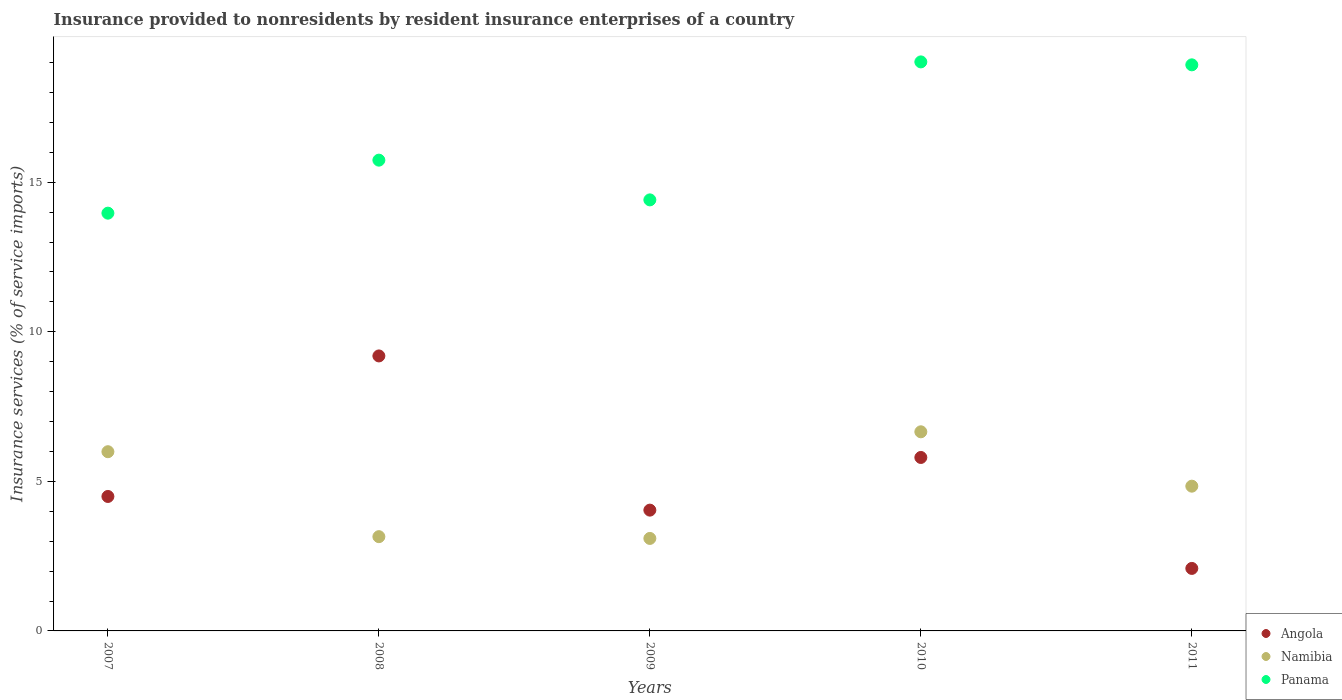How many different coloured dotlines are there?
Keep it short and to the point. 3. Is the number of dotlines equal to the number of legend labels?
Provide a succinct answer. Yes. What is the insurance provided to nonresidents in Angola in 2009?
Ensure brevity in your answer.  4.04. Across all years, what is the maximum insurance provided to nonresidents in Namibia?
Your response must be concise. 6.66. Across all years, what is the minimum insurance provided to nonresidents in Angola?
Keep it short and to the point. 2.09. What is the total insurance provided to nonresidents in Namibia in the graph?
Make the answer very short. 23.73. What is the difference between the insurance provided to nonresidents in Panama in 2009 and that in 2011?
Offer a very short reply. -4.51. What is the difference between the insurance provided to nonresidents in Angola in 2007 and the insurance provided to nonresidents in Namibia in 2008?
Make the answer very short. 1.34. What is the average insurance provided to nonresidents in Namibia per year?
Give a very brief answer. 4.75. In the year 2007, what is the difference between the insurance provided to nonresidents in Panama and insurance provided to nonresidents in Angola?
Your answer should be very brief. 9.47. What is the ratio of the insurance provided to nonresidents in Panama in 2010 to that in 2011?
Ensure brevity in your answer.  1.01. What is the difference between the highest and the second highest insurance provided to nonresidents in Angola?
Your answer should be very brief. 3.39. What is the difference between the highest and the lowest insurance provided to nonresidents in Namibia?
Give a very brief answer. 3.56. In how many years, is the insurance provided to nonresidents in Namibia greater than the average insurance provided to nonresidents in Namibia taken over all years?
Offer a terse response. 3. Is it the case that in every year, the sum of the insurance provided to nonresidents in Namibia and insurance provided to nonresidents in Panama  is greater than the insurance provided to nonresidents in Angola?
Your answer should be compact. Yes. Does the insurance provided to nonresidents in Namibia monotonically increase over the years?
Give a very brief answer. No. Is the insurance provided to nonresidents in Namibia strictly greater than the insurance provided to nonresidents in Panama over the years?
Provide a succinct answer. No. Is the insurance provided to nonresidents in Namibia strictly less than the insurance provided to nonresidents in Panama over the years?
Offer a terse response. Yes. How many dotlines are there?
Offer a terse response. 3. How many years are there in the graph?
Your answer should be compact. 5. Are the values on the major ticks of Y-axis written in scientific E-notation?
Your answer should be compact. No. Does the graph contain any zero values?
Make the answer very short. No. Does the graph contain grids?
Your answer should be very brief. No. How many legend labels are there?
Ensure brevity in your answer.  3. How are the legend labels stacked?
Offer a very short reply. Vertical. What is the title of the graph?
Make the answer very short. Insurance provided to nonresidents by resident insurance enterprises of a country. What is the label or title of the Y-axis?
Provide a succinct answer. Insurance services (% of service imports). What is the Insurance services (% of service imports) of Angola in 2007?
Offer a very short reply. 4.49. What is the Insurance services (% of service imports) in Namibia in 2007?
Your answer should be very brief. 5.99. What is the Insurance services (% of service imports) of Panama in 2007?
Your answer should be compact. 13.97. What is the Insurance services (% of service imports) in Angola in 2008?
Provide a succinct answer. 9.19. What is the Insurance services (% of service imports) of Namibia in 2008?
Provide a short and direct response. 3.15. What is the Insurance services (% of service imports) in Panama in 2008?
Offer a very short reply. 15.74. What is the Insurance services (% of service imports) in Angola in 2009?
Offer a very short reply. 4.04. What is the Insurance services (% of service imports) in Namibia in 2009?
Your answer should be compact. 3.09. What is the Insurance services (% of service imports) of Panama in 2009?
Ensure brevity in your answer.  14.41. What is the Insurance services (% of service imports) in Angola in 2010?
Your response must be concise. 5.8. What is the Insurance services (% of service imports) of Namibia in 2010?
Offer a very short reply. 6.66. What is the Insurance services (% of service imports) in Panama in 2010?
Your answer should be compact. 19.02. What is the Insurance services (% of service imports) in Angola in 2011?
Provide a succinct answer. 2.09. What is the Insurance services (% of service imports) of Namibia in 2011?
Your response must be concise. 4.84. What is the Insurance services (% of service imports) in Panama in 2011?
Offer a terse response. 18.92. Across all years, what is the maximum Insurance services (% of service imports) in Angola?
Give a very brief answer. 9.19. Across all years, what is the maximum Insurance services (% of service imports) in Namibia?
Provide a succinct answer. 6.66. Across all years, what is the maximum Insurance services (% of service imports) in Panama?
Offer a terse response. 19.02. Across all years, what is the minimum Insurance services (% of service imports) in Angola?
Offer a terse response. 2.09. Across all years, what is the minimum Insurance services (% of service imports) of Namibia?
Your answer should be compact. 3.09. Across all years, what is the minimum Insurance services (% of service imports) of Panama?
Offer a very short reply. 13.97. What is the total Insurance services (% of service imports) in Angola in the graph?
Your answer should be compact. 25.61. What is the total Insurance services (% of service imports) of Namibia in the graph?
Your answer should be compact. 23.73. What is the total Insurance services (% of service imports) of Panama in the graph?
Provide a succinct answer. 82.06. What is the difference between the Insurance services (% of service imports) of Angola in 2007 and that in 2008?
Give a very brief answer. -4.7. What is the difference between the Insurance services (% of service imports) of Namibia in 2007 and that in 2008?
Your response must be concise. 2.84. What is the difference between the Insurance services (% of service imports) of Panama in 2007 and that in 2008?
Your response must be concise. -1.77. What is the difference between the Insurance services (% of service imports) of Angola in 2007 and that in 2009?
Provide a succinct answer. 0.46. What is the difference between the Insurance services (% of service imports) in Namibia in 2007 and that in 2009?
Offer a terse response. 2.9. What is the difference between the Insurance services (% of service imports) of Panama in 2007 and that in 2009?
Give a very brief answer. -0.44. What is the difference between the Insurance services (% of service imports) of Angola in 2007 and that in 2010?
Your answer should be very brief. -1.3. What is the difference between the Insurance services (% of service imports) of Namibia in 2007 and that in 2010?
Ensure brevity in your answer.  -0.67. What is the difference between the Insurance services (% of service imports) of Panama in 2007 and that in 2010?
Give a very brief answer. -5.06. What is the difference between the Insurance services (% of service imports) of Angola in 2007 and that in 2011?
Offer a terse response. 2.41. What is the difference between the Insurance services (% of service imports) of Namibia in 2007 and that in 2011?
Offer a very short reply. 1.15. What is the difference between the Insurance services (% of service imports) of Panama in 2007 and that in 2011?
Your response must be concise. -4.96. What is the difference between the Insurance services (% of service imports) of Angola in 2008 and that in 2009?
Keep it short and to the point. 5.15. What is the difference between the Insurance services (% of service imports) of Namibia in 2008 and that in 2009?
Your answer should be very brief. 0.06. What is the difference between the Insurance services (% of service imports) in Panama in 2008 and that in 2009?
Provide a succinct answer. 1.33. What is the difference between the Insurance services (% of service imports) in Angola in 2008 and that in 2010?
Give a very brief answer. 3.39. What is the difference between the Insurance services (% of service imports) of Namibia in 2008 and that in 2010?
Make the answer very short. -3.51. What is the difference between the Insurance services (% of service imports) in Panama in 2008 and that in 2010?
Ensure brevity in your answer.  -3.28. What is the difference between the Insurance services (% of service imports) of Angola in 2008 and that in 2011?
Your answer should be compact. 7.1. What is the difference between the Insurance services (% of service imports) of Namibia in 2008 and that in 2011?
Offer a very short reply. -1.69. What is the difference between the Insurance services (% of service imports) in Panama in 2008 and that in 2011?
Ensure brevity in your answer.  -3.19. What is the difference between the Insurance services (% of service imports) in Angola in 2009 and that in 2010?
Ensure brevity in your answer.  -1.76. What is the difference between the Insurance services (% of service imports) of Namibia in 2009 and that in 2010?
Provide a succinct answer. -3.56. What is the difference between the Insurance services (% of service imports) in Panama in 2009 and that in 2010?
Give a very brief answer. -4.61. What is the difference between the Insurance services (% of service imports) of Angola in 2009 and that in 2011?
Your response must be concise. 1.95. What is the difference between the Insurance services (% of service imports) of Namibia in 2009 and that in 2011?
Your response must be concise. -1.75. What is the difference between the Insurance services (% of service imports) in Panama in 2009 and that in 2011?
Make the answer very short. -4.51. What is the difference between the Insurance services (% of service imports) of Angola in 2010 and that in 2011?
Your response must be concise. 3.71. What is the difference between the Insurance services (% of service imports) in Namibia in 2010 and that in 2011?
Your answer should be very brief. 1.82. What is the difference between the Insurance services (% of service imports) in Panama in 2010 and that in 2011?
Offer a terse response. 0.1. What is the difference between the Insurance services (% of service imports) of Angola in 2007 and the Insurance services (% of service imports) of Namibia in 2008?
Provide a succinct answer. 1.34. What is the difference between the Insurance services (% of service imports) in Angola in 2007 and the Insurance services (% of service imports) in Panama in 2008?
Keep it short and to the point. -11.24. What is the difference between the Insurance services (% of service imports) in Namibia in 2007 and the Insurance services (% of service imports) in Panama in 2008?
Provide a short and direct response. -9.75. What is the difference between the Insurance services (% of service imports) of Angola in 2007 and the Insurance services (% of service imports) of Namibia in 2009?
Provide a short and direct response. 1.4. What is the difference between the Insurance services (% of service imports) of Angola in 2007 and the Insurance services (% of service imports) of Panama in 2009?
Your response must be concise. -9.91. What is the difference between the Insurance services (% of service imports) in Namibia in 2007 and the Insurance services (% of service imports) in Panama in 2009?
Offer a terse response. -8.42. What is the difference between the Insurance services (% of service imports) of Angola in 2007 and the Insurance services (% of service imports) of Namibia in 2010?
Provide a short and direct response. -2.16. What is the difference between the Insurance services (% of service imports) of Angola in 2007 and the Insurance services (% of service imports) of Panama in 2010?
Offer a terse response. -14.53. What is the difference between the Insurance services (% of service imports) of Namibia in 2007 and the Insurance services (% of service imports) of Panama in 2010?
Ensure brevity in your answer.  -13.03. What is the difference between the Insurance services (% of service imports) in Angola in 2007 and the Insurance services (% of service imports) in Namibia in 2011?
Keep it short and to the point. -0.34. What is the difference between the Insurance services (% of service imports) in Angola in 2007 and the Insurance services (% of service imports) in Panama in 2011?
Provide a succinct answer. -14.43. What is the difference between the Insurance services (% of service imports) in Namibia in 2007 and the Insurance services (% of service imports) in Panama in 2011?
Ensure brevity in your answer.  -12.93. What is the difference between the Insurance services (% of service imports) of Angola in 2008 and the Insurance services (% of service imports) of Namibia in 2009?
Your response must be concise. 6.1. What is the difference between the Insurance services (% of service imports) of Angola in 2008 and the Insurance services (% of service imports) of Panama in 2009?
Keep it short and to the point. -5.22. What is the difference between the Insurance services (% of service imports) in Namibia in 2008 and the Insurance services (% of service imports) in Panama in 2009?
Keep it short and to the point. -11.26. What is the difference between the Insurance services (% of service imports) in Angola in 2008 and the Insurance services (% of service imports) in Namibia in 2010?
Offer a terse response. 2.54. What is the difference between the Insurance services (% of service imports) of Angola in 2008 and the Insurance services (% of service imports) of Panama in 2010?
Make the answer very short. -9.83. What is the difference between the Insurance services (% of service imports) in Namibia in 2008 and the Insurance services (% of service imports) in Panama in 2010?
Provide a short and direct response. -15.87. What is the difference between the Insurance services (% of service imports) in Angola in 2008 and the Insurance services (% of service imports) in Namibia in 2011?
Ensure brevity in your answer.  4.35. What is the difference between the Insurance services (% of service imports) in Angola in 2008 and the Insurance services (% of service imports) in Panama in 2011?
Offer a terse response. -9.73. What is the difference between the Insurance services (% of service imports) of Namibia in 2008 and the Insurance services (% of service imports) of Panama in 2011?
Your response must be concise. -15.77. What is the difference between the Insurance services (% of service imports) in Angola in 2009 and the Insurance services (% of service imports) in Namibia in 2010?
Your response must be concise. -2.62. What is the difference between the Insurance services (% of service imports) of Angola in 2009 and the Insurance services (% of service imports) of Panama in 2010?
Provide a short and direct response. -14.98. What is the difference between the Insurance services (% of service imports) in Namibia in 2009 and the Insurance services (% of service imports) in Panama in 2010?
Make the answer very short. -15.93. What is the difference between the Insurance services (% of service imports) of Angola in 2009 and the Insurance services (% of service imports) of Namibia in 2011?
Your answer should be very brief. -0.8. What is the difference between the Insurance services (% of service imports) of Angola in 2009 and the Insurance services (% of service imports) of Panama in 2011?
Your response must be concise. -14.89. What is the difference between the Insurance services (% of service imports) in Namibia in 2009 and the Insurance services (% of service imports) in Panama in 2011?
Your response must be concise. -15.83. What is the difference between the Insurance services (% of service imports) in Angola in 2010 and the Insurance services (% of service imports) in Namibia in 2011?
Provide a succinct answer. 0.96. What is the difference between the Insurance services (% of service imports) of Angola in 2010 and the Insurance services (% of service imports) of Panama in 2011?
Give a very brief answer. -13.13. What is the difference between the Insurance services (% of service imports) of Namibia in 2010 and the Insurance services (% of service imports) of Panama in 2011?
Provide a succinct answer. -12.27. What is the average Insurance services (% of service imports) in Angola per year?
Keep it short and to the point. 5.12. What is the average Insurance services (% of service imports) of Namibia per year?
Your answer should be very brief. 4.75. What is the average Insurance services (% of service imports) of Panama per year?
Your answer should be very brief. 16.41. In the year 2007, what is the difference between the Insurance services (% of service imports) of Angola and Insurance services (% of service imports) of Namibia?
Provide a short and direct response. -1.5. In the year 2007, what is the difference between the Insurance services (% of service imports) in Angola and Insurance services (% of service imports) in Panama?
Your answer should be compact. -9.47. In the year 2007, what is the difference between the Insurance services (% of service imports) of Namibia and Insurance services (% of service imports) of Panama?
Keep it short and to the point. -7.97. In the year 2008, what is the difference between the Insurance services (% of service imports) of Angola and Insurance services (% of service imports) of Namibia?
Give a very brief answer. 6.04. In the year 2008, what is the difference between the Insurance services (% of service imports) of Angola and Insurance services (% of service imports) of Panama?
Offer a terse response. -6.55. In the year 2008, what is the difference between the Insurance services (% of service imports) in Namibia and Insurance services (% of service imports) in Panama?
Provide a short and direct response. -12.59. In the year 2009, what is the difference between the Insurance services (% of service imports) of Angola and Insurance services (% of service imports) of Namibia?
Offer a very short reply. 0.95. In the year 2009, what is the difference between the Insurance services (% of service imports) in Angola and Insurance services (% of service imports) in Panama?
Your answer should be compact. -10.37. In the year 2009, what is the difference between the Insurance services (% of service imports) of Namibia and Insurance services (% of service imports) of Panama?
Give a very brief answer. -11.32. In the year 2010, what is the difference between the Insurance services (% of service imports) of Angola and Insurance services (% of service imports) of Namibia?
Your answer should be very brief. -0.86. In the year 2010, what is the difference between the Insurance services (% of service imports) of Angola and Insurance services (% of service imports) of Panama?
Offer a very short reply. -13.22. In the year 2010, what is the difference between the Insurance services (% of service imports) of Namibia and Insurance services (% of service imports) of Panama?
Your answer should be very brief. -12.37. In the year 2011, what is the difference between the Insurance services (% of service imports) in Angola and Insurance services (% of service imports) in Namibia?
Ensure brevity in your answer.  -2.75. In the year 2011, what is the difference between the Insurance services (% of service imports) in Angola and Insurance services (% of service imports) in Panama?
Keep it short and to the point. -16.83. In the year 2011, what is the difference between the Insurance services (% of service imports) of Namibia and Insurance services (% of service imports) of Panama?
Your answer should be very brief. -14.09. What is the ratio of the Insurance services (% of service imports) of Angola in 2007 to that in 2008?
Offer a very short reply. 0.49. What is the ratio of the Insurance services (% of service imports) of Namibia in 2007 to that in 2008?
Provide a short and direct response. 1.9. What is the ratio of the Insurance services (% of service imports) of Panama in 2007 to that in 2008?
Keep it short and to the point. 0.89. What is the ratio of the Insurance services (% of service imports) of Angola in 2007 to that in 2009?
Make the answer very short. 1.11. What is the ratio of the Insurance services (% of service imports) in Namibia in 2007 to that in 2009?
Give a very brief answer. 1.94. What is the ratio of the Insurance services (% of service imports) in Panama in 2007 to that in 2009?
Keep it short and to the point. 0.97. What is the ratio of the Insurance services (% of service imports) in Angola in 2007 to that in 2010?
Keep it short and to the point. 0.78. What is the ratio of the Insurance services (% of service imports) of Panama in 2007 to that in 2010?
Provide a succinct answer. 0.73. What is the ratio of the Insurance services (% of service imports) of Angola in 2007 to that in 2011?
Provide a short and direct response. 2.15. What is the ratio of the Insurance services (% of service imports) of Namibia in 2007 to that in 2011?
Give a very brief answer. 1.24. What is the ratio of the Insurance services (% of service imports) of Panama in 2007 to that in 2011?
Offer a terse response. 0.74. What is the ratio of the Insurance services (% of service imports) of Angola in 2008 to that in 2009?
Your answer should be very brief. 2.28. What is the ratio of the Insurance services (% of service imports) in Namibia in 2008 to that in 2009?
Offer a very short reply. 1.02. What is the ratio of the Insurance services (% of service imports) in Panama in 2008 to that in 2009?
Give a very brief answer. 1.09. What is the ratio of the Insurance services (% of service imports) of Angola in 2008 to that in 2010?
Make the answer very short. 1.59. What is the ratio of the Insurance services (% of service imports) of Namibia in 2008 to that in 2010?
Offer a very short reply. 0.47. What is the ratio of the Insurance services (% of service imports) in Panama in 2008 to that in 2010?
Give a very brief answer. 0.83. What is the ratio of the Insurance services (% of service imports) of Angola in 2008 to that in 2011?
Give a very brief answer. 4.4. What is the ratio of the Insurance services (% of service imports) in Namibia in 2008 to that in 2011?
Keep it short and to the point. 0.65. What is the ratio of the Insurance services (% of service imports) in Panama in 2008 to that in 2011?
Your answer should be compact. 0.83. What is the ratio of the Insurance services (% of service imports) of Angola in 2009 to that in 2010?
Offer a very short reply. 0.7. What is the ratio of the Insurance services (% of service imports) in Namibia in 2009 to that in 2010?
Offer a very short reply. 0.46. What is the ratio of the Insurance services (% of service imports) of Panama in 2009 to that in 2010?
Keep it short and to the point. 0.76. What is the ratio of the Insurance services (% of service imports) in Angola in 2009 to that in 2011?
Offer a very short reply. 1.93. What is the ratio of the Insurance services (% of service imports) of Namibia in 2009 to that in 2011?
Your answer should be compact. 0.64. What is the ratio of the Insurance services (% of service imports) of Panama in 2009 to that in 2011?
Offer a very short reply. 0.76. What is the ratio of the Insurance services (% of service imports) in Angola in 2010 to that in 2011?
Offer a terse response. 2.78. What is the ratio of the Insurance services (% of service imports) of Namibia in 2010 to that in 2011?
Offer a very short reply. 1.38. What is the ratio of the Insurance services (% of service imports) in Panama in 2010 to that in 2011?
Provide a short and direct response. 1.01. What is the difference between the highest and the second highest Insurance services (% of service imports) in Angola?
Your answer should be very brief. 3.39. What is the difference between the highest and the second highest Insurance services (% of service imports) in Namibia?
Give a very brief answer. 0.67. What is the difference between the highest and the second highest Insurance services (% of service imports) in Panama?
Offer a terse response. 0.1. What is the difference between the highest and the lowest Insurance services (% of service imports) in Angola?
Make the answer very short. 7.1. What is the difference between the highest and the lowest Insurance services (% of service imports) of Namibia?
Your answer should be very brief. 3.56. What is the difference between the highest and the lowest Insurance services (% of service imports) of Panama?
Your response must be concise. 5.06. 